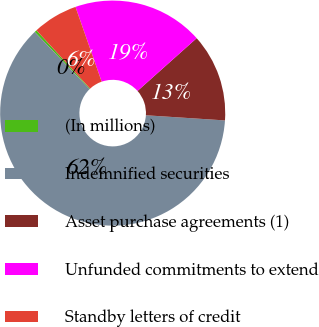<chart> <loc_0><loc_0><loc_500><loc_500><pie_chart><fcel>(In millions)<fcel>Indemnified securities<fcel>Asset purchase agreements (1)<fcel>Unfunded commitments to extend<fcel>Standby letters of credit<nl><fcel>0.34%<fcel>61.78%<fcel>12.63%<fcel>18.77%<fcel>6.48%<nl></chart> 